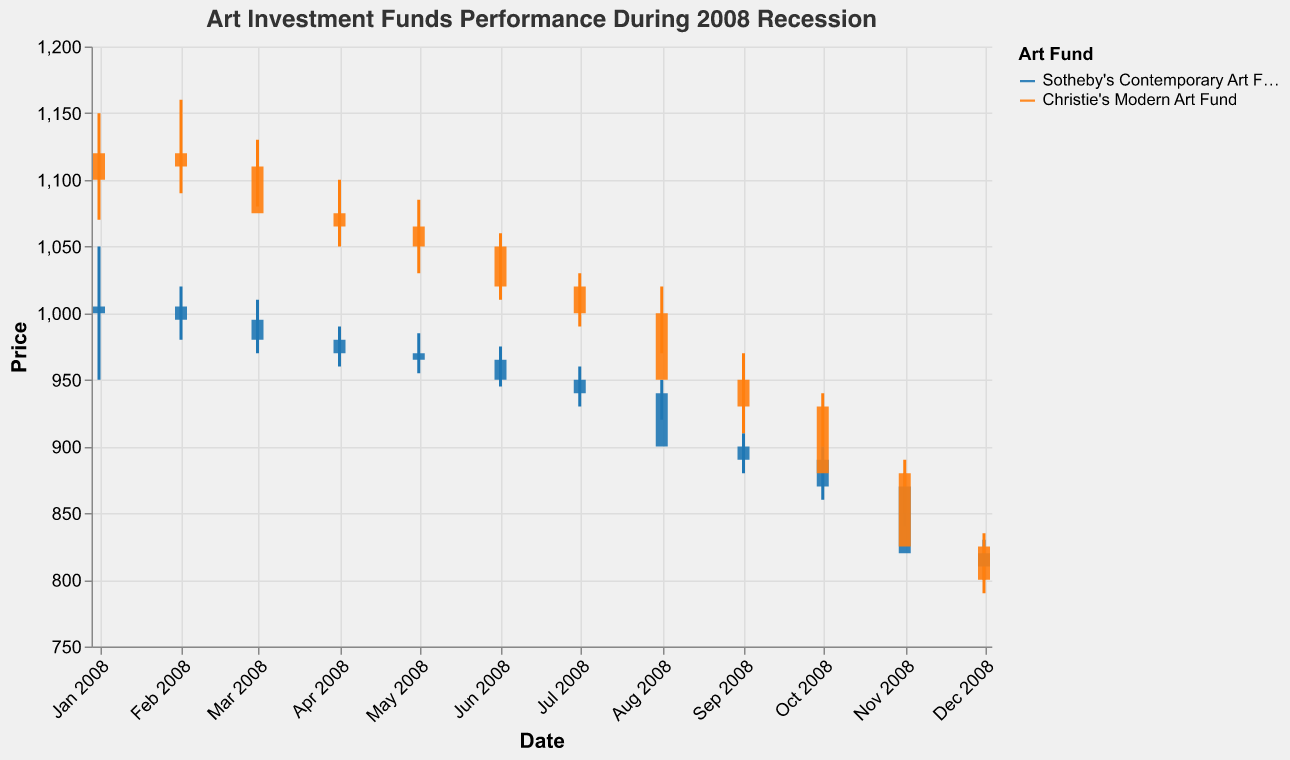What is the title of the chart? The title is located at the top of the chart. It reads clearly in larger font text.
Answer: Art Investment Funds Performance During 2008 Recession How does the value of Sotheby's Contemporary Art Fund change from January 2008 to December 2008? You can track the "Close" prices for Sotheby's Contemporary Art Fund for each month from January to December.
Answer: It decreases from 1005 to 810 Which Art Fund showed higher open prices in October 2008? Compare the "Open" prices for both Sotheby's Contemporary Art Fund and Christie's Modern Art Fund in October 2008.
Answer: Christie's Modern Art Fund What is the range of closing prices for Christie's Modern Art Fund in 2008? Look at the "Close" prices for Christie's Modern Art Fund from January to December and identify the minimum and maximum closing values.
Answer: 800 to 1120 Which month shows the highest trading volume for Sotheby's Contemporary Art Fund in 2008? Examine the "Volume" values for Sotheby's Contemporary Art Fund for each month and identify the highest.
Answer: December 2008 Compare the closing prices of both art funds in June 2008. Check the "Close" prices for Sotheby's Contemporary Art Fund and Christie's Modern Art Fund in June 2008 and compare them.
Answer: Sotheby's: 950; Christie's: 1020 During which months did Christie's Modern Art Fund see a decline in the closing price from the previous month? By comparing the "Close" prices for each month of Christie's Modern Art Fund, identify the months where the value decreased compared to the previous month.
Answer: March, April, June, August, September, October, November, December What is the median closing price of Sotheby's Contemporary Art Fund in 2008? Collect the "Close" prices for each month for Sotheby's Contemporary Art Fund, sort them, and find the middle value. (950, 965, 970, 980, 990, 995, 1005) / 7
Answer: 970 Which Art Fund had a smaller decline percentage-wise from January to December 2008? Calculate the percentage decline for each fund by subtracting the December "Close" price from the January "Close" price, dividing by the January "Close" price, and multiplying by 100.
Answer: Christie's Modern Art Fund In which month did both art funds experience their lowest closing prices in 2008? Check the "Close" prices of both art funds and identify the month when each had its lowest closing price.
Answer: December 2008 